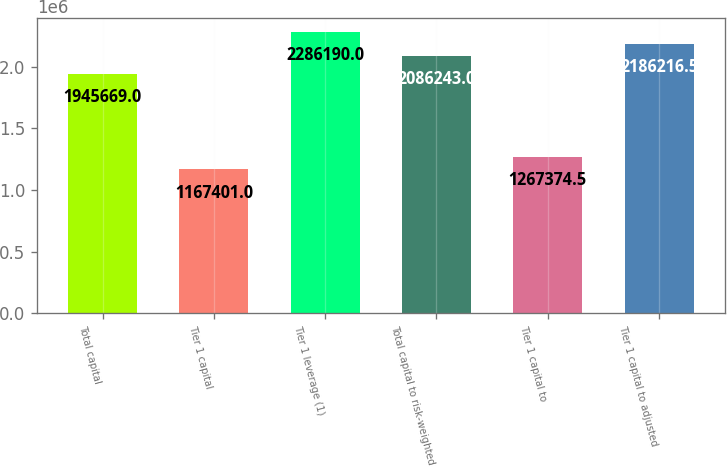Convert chart to OTSL. <chart><loc_0><loc_0><loc_500><loc_500><bar_chart><fcel>Total capital<fcel>Tier 1 capital<fcel>Tier 1 leverage (1)<fcel>Total capital to risk-weighted<fcel>Tier 1 capital to<fcel>Tier 1 capital to adjusted<nl><fcel>1.94567e+06<fcel>1.1674e+06<fcel>2.28619e+06<fcel>2.08624e+06<fcel>1.26737e+06<fcel>2.18622e+06<nl></chart> 